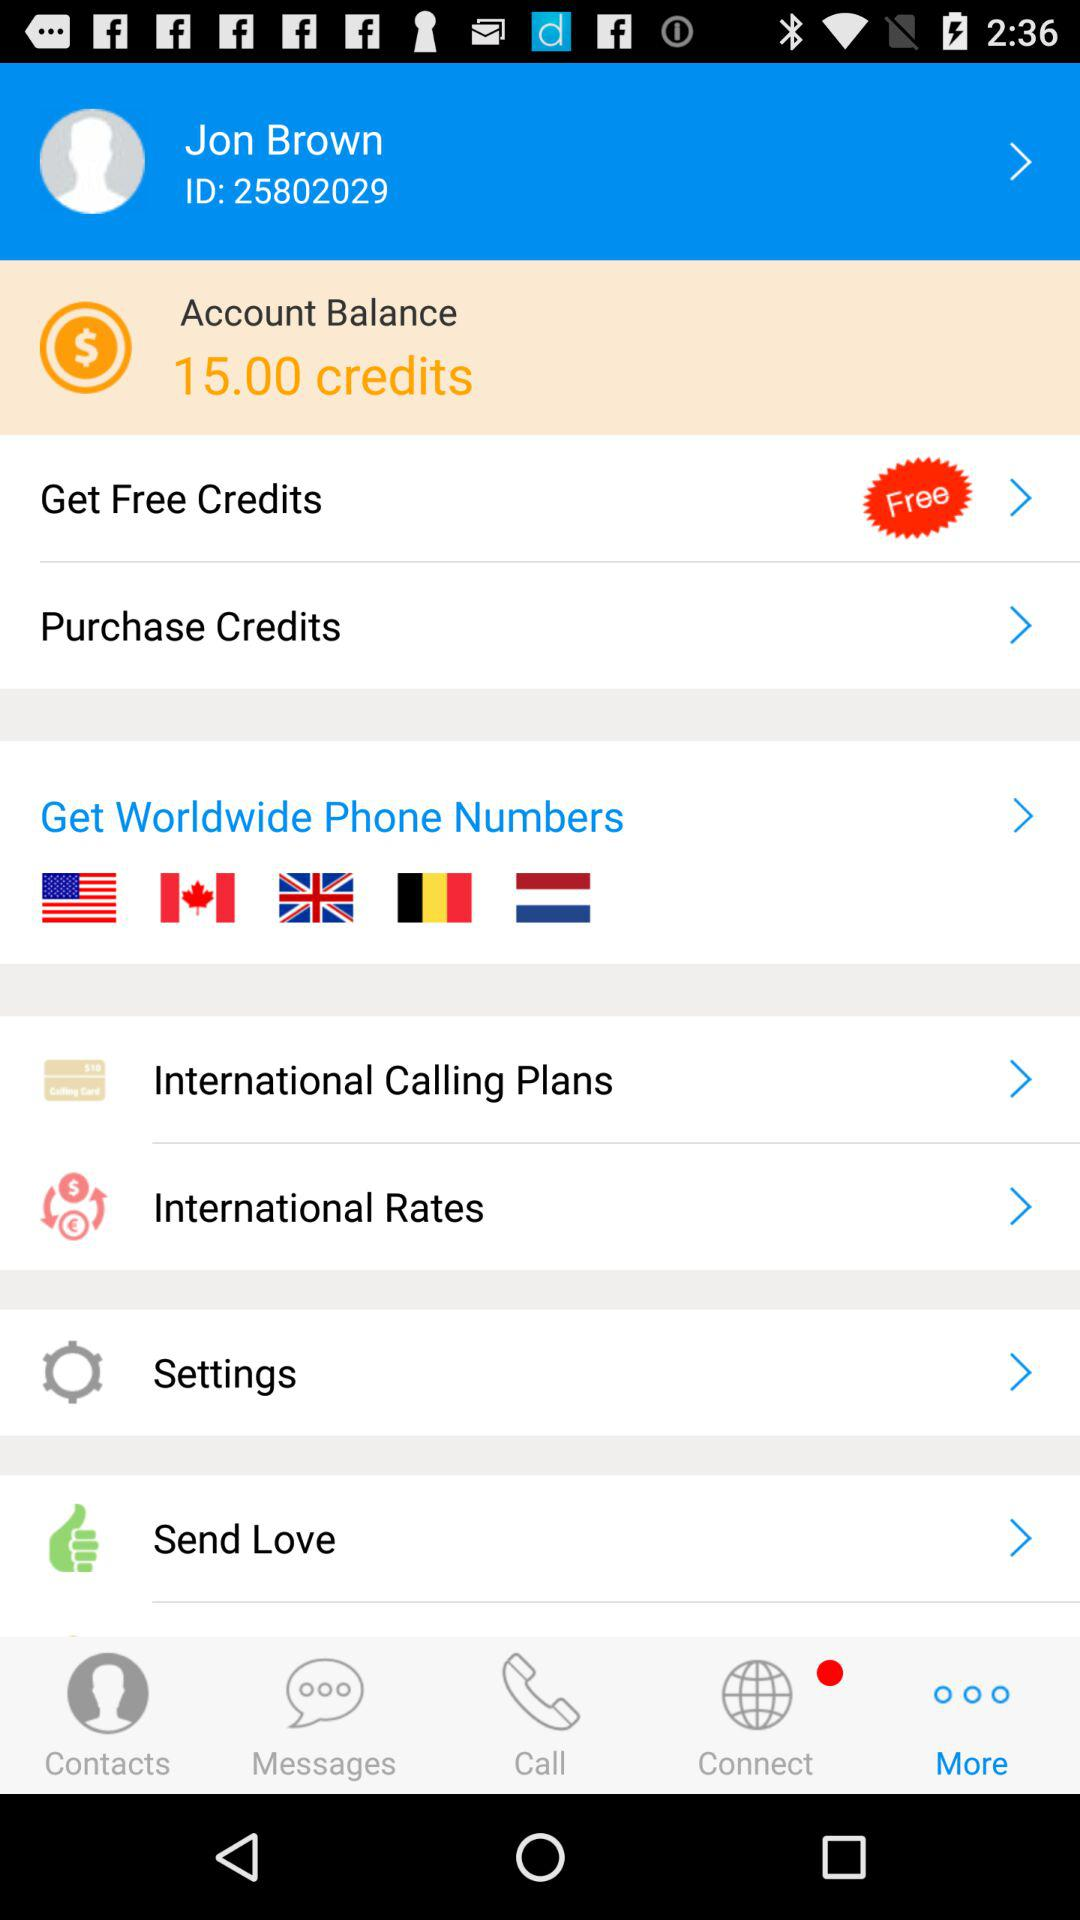What is the name of the user? The name of the user is "Jon Brown". 